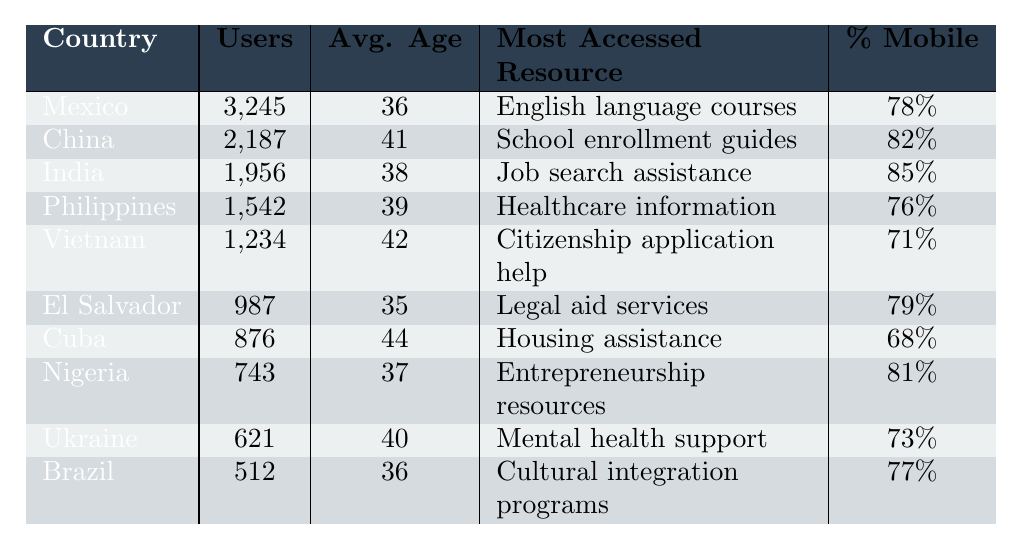What country has the highest number of users accessing the website? By looking at the "Users" column, we see that Mexico has 3,245 users, which is the highest compared to all other countries listed in the table.
Answer: Mexico What is the average age of users from India? The table directly lists the average age for India, which is 38 years old.
Answer: 38 Which resource is most accessed by users from China? The "Most Accessed Resource" column indicates that users from China most frequently access school enrollment guides.
Answer: School enrollment guides What percentage of users from Vietnam access the website via mobile? According to the "Percentage Mobile" column, 71% of users from Vietnam access the website using mobile devices.
Answer: 71% Calculate the average age of all users listed in the table. First, add the average ages: (36 + 41 + 38 + 39 + 42 + 35 + 44 + 37 + 40 + 36) =  398. Then, divide by the number of countries (10): 398 / 10 = 39.8.
Answer: 39.8 Is the most accessed resource for Nigeria entrepreneurship resources? Looking in the "Most Accessed Resource" column for Nigeria shows it is listed as "Entrepreneurship resources," which confirms the statement to be true.
Answer: Yes Which country has a higher percentage of mobile users, Cuba or the Philippines? Cuba has 68% and the Philippines has 76% in the "Percentage Mobile" column. Since 76% (Philippines) is greater than 68% (Cuba), the Philippines has a higher percentage.
Answer: Philippines What is the total number of users from all countries combined? To find the total, add up all the users: (3245 + 2187 + 1956 + 1542 + 1234 + 987 + 876 + 743 + 621 + 512) = 13,052 users total.
Answer: 13,052 Which country has the lowest number of users accessing the website? By assessing the "Users" column, Brazil has the lowest number, with 512 users, when comparing all the data.
Answer: Brazil Compare the average age of users from Mexico and China. Which country has older users? Mexico's average age is 36, while China's is 41. Since 41 is greater than 36, users from China are older on average.
Answer: China 